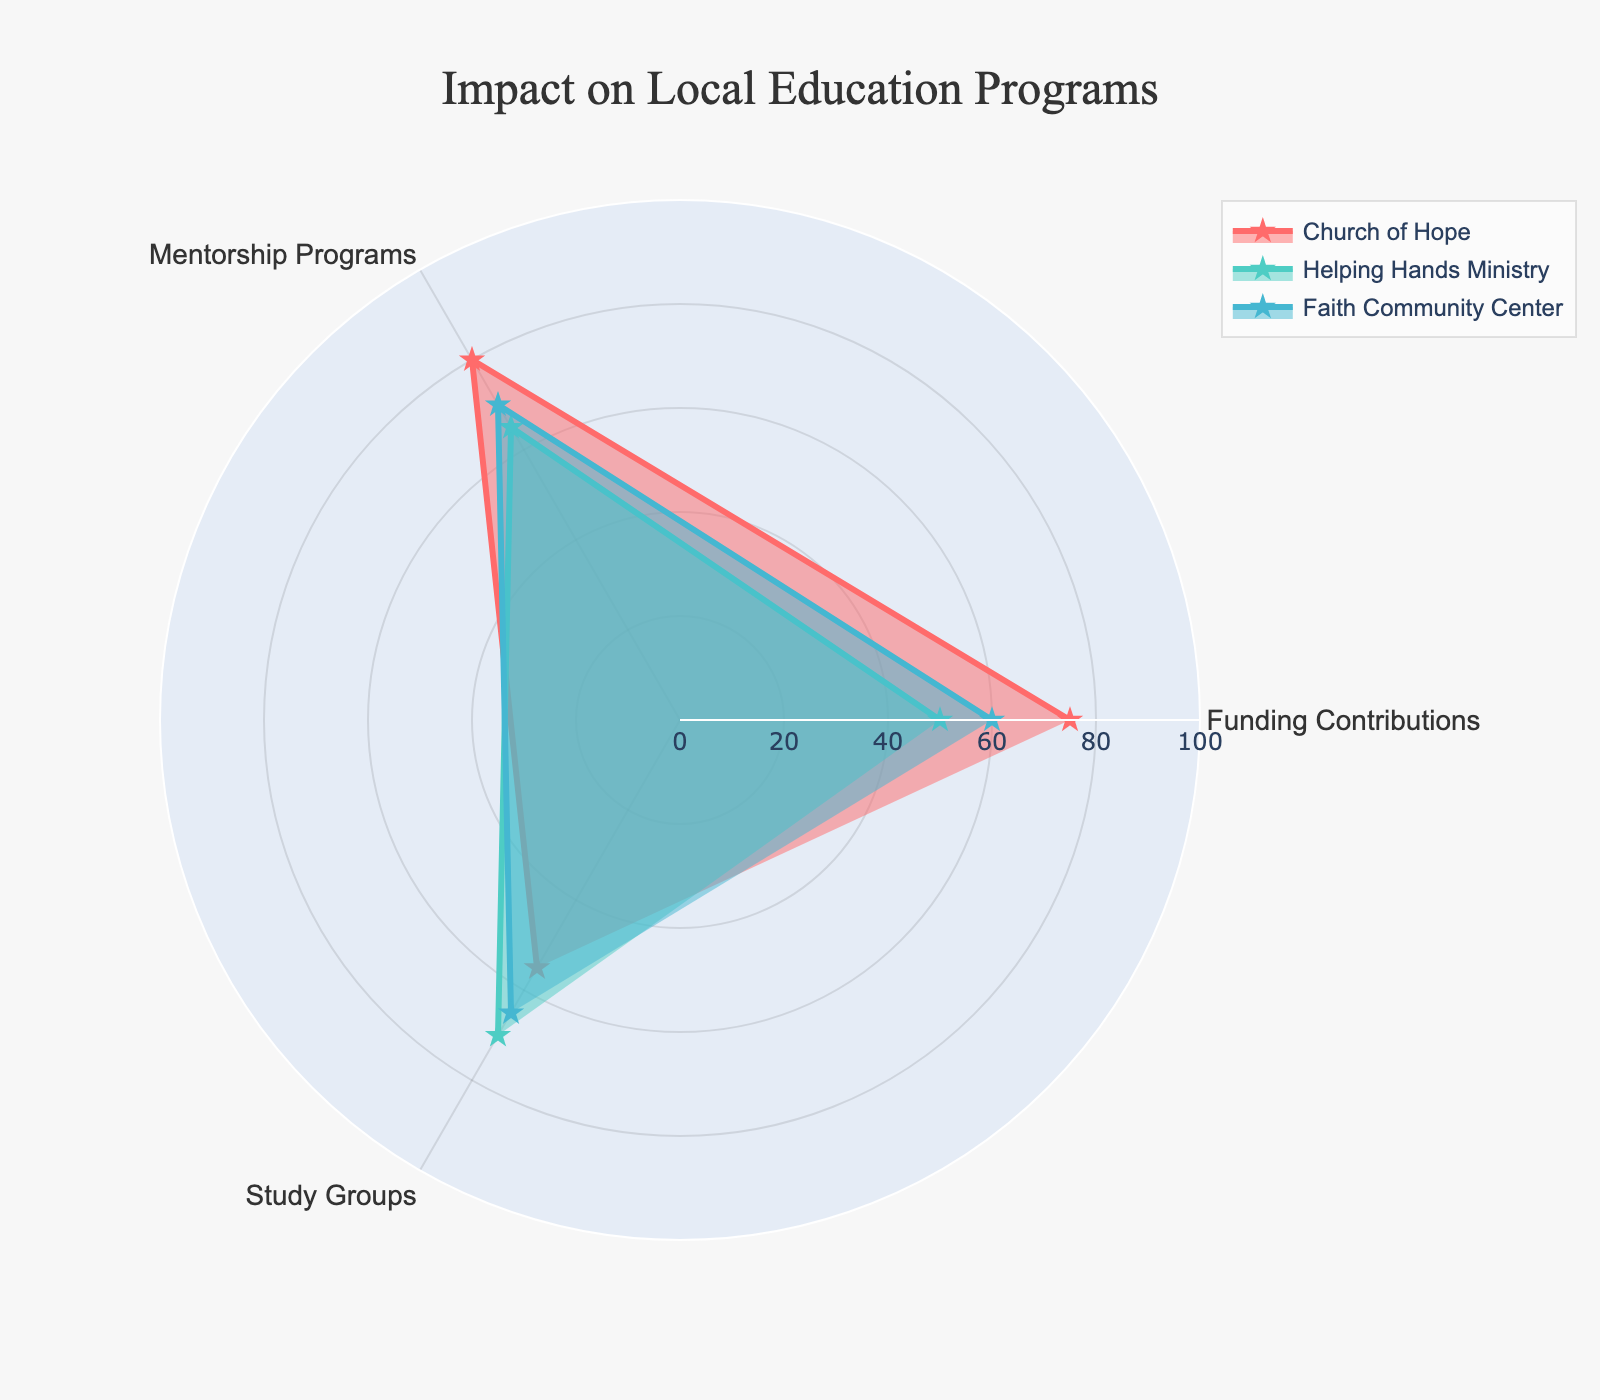What is the title of the radar chart? The title of the radar chart is usually found at the top center of the figure. It provides a high-level summary of what the chart is about.
Answer: Impact on Local Education Programs Which category does the Church of Hope have the highest score in? The radial axis in the radar chart shows the categories, and the Church of Hope's values are plotted along these axes. The highest point on the Church of Hope's shape indicates the category with the highest score.
Answer: Mentorship Programs How does Helping Hands Ministry's funding contributions compare to their study groups' scores? By looking at the data points for Helping Hands Ministry in both the Funding Contributions and Study Groups axes, we can compare them directly.
Answer: Funding Contributions (50) are lower than Study Groups (70) What is the average score of Faith Community Center across all categories? To find the average score, sum the scores of Faith Community Center across all categories and divide by the number of categories. (60+70+65) / 3 = 195 / 3.
Answer: 65 Which organization has the highest score in Study Groups? Check the Study Groups axis for the highest plotted point among the three organizations' colored shapes.
Answer: Helping Hands Ministry What is the difference between the highest and lowest score for Church of Hope? Identify the highest and lowest scores of Church of Hope across all categories and calculate their difference: Mentorship Programs (80) - Study Groups (55).
Answer: 25 Compare the overall visual area covered by each organization. Which organization appears to have the greatest overall impact? The overall area covered by each organization's shape represents their combined impact across all categories. The organization with the largest filled area generally indicates the greatest overall impact.
Answer: Church of Hope Is there any category where Faith Community Center scores exactly in the middle of the scores of the other two organizations? Look at each category and check if Faith Community Center's score falls between the scores of the other two organizations.
Answer: Study Groups How do the mentorship programs scores compare among the three organizations? By observing the Mentorship Programs axis, compare the three plotted points for the organizations.
Answer: Church of Hope (80) > Faith Community Center (70) > Helping Hands Ministry (65) What is unique about the Church of Hope’s contributions in terms of their variability across categories? Assess the range or spread of the Church of Hope’s scores across the three categories to identify their variability. The less variability, the more consistent their contributions.
Answer: Church of Hope shows the highest variability with scores ranging from 55 to 80 